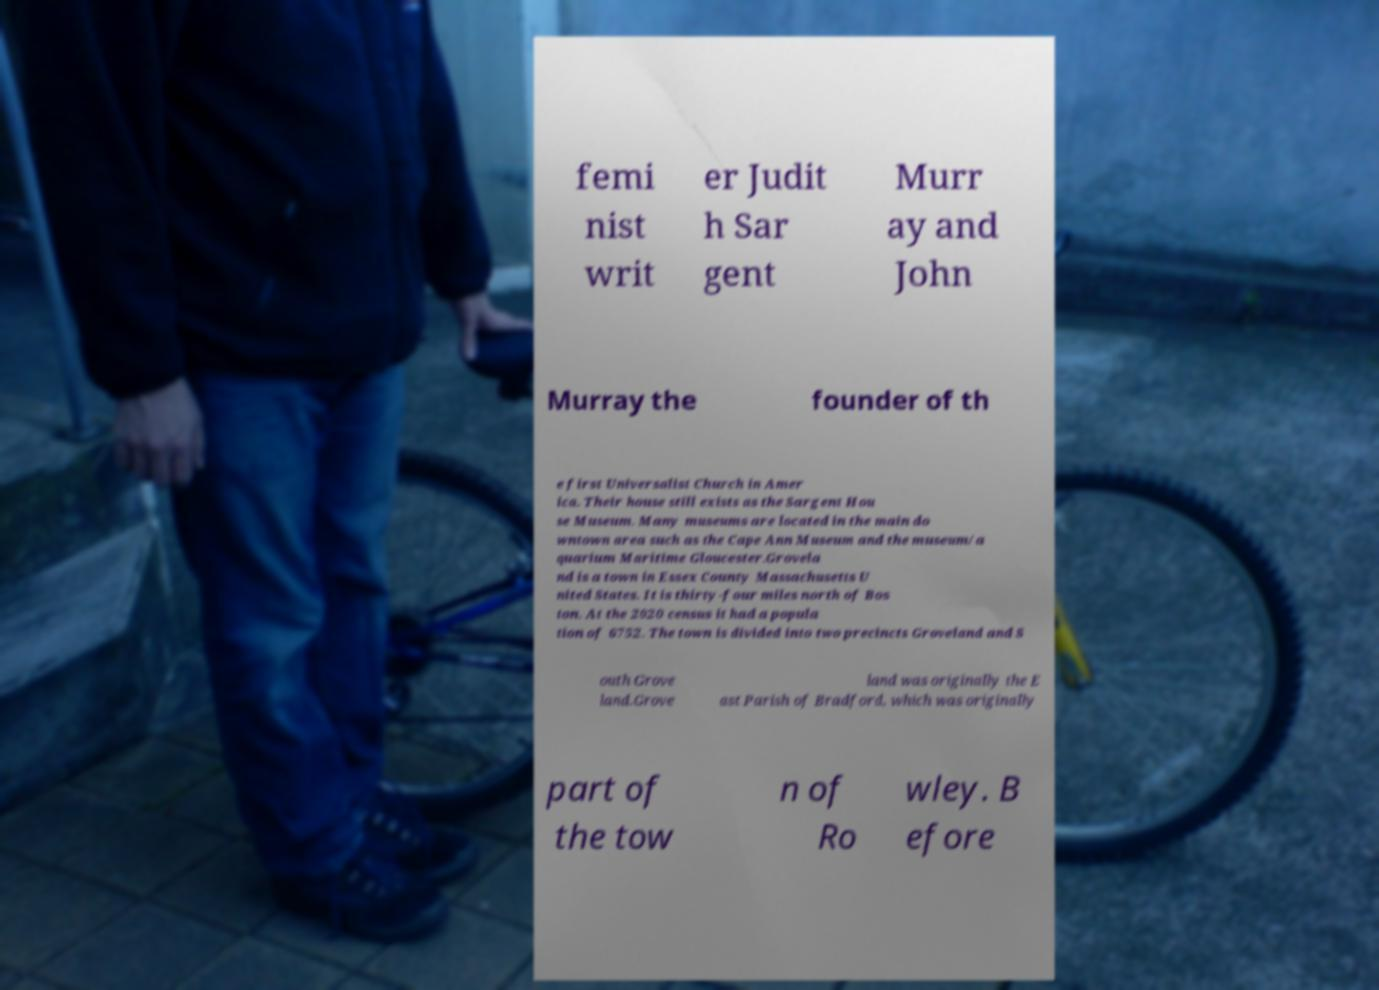What messages or text are displayed in this image? I need them in a readable, typed format. femi nist writ er Judit h Sar gent Murr ay and John Murray the founder of th e first Universalist Church in Amer ica. Their house still exists as the Sargent Hou se Museum. Many museums are located in the main do wntown area such as the Cape Ann Museum and the museum/a quarium Maritime Gloucester.Grovela nd is a town in Essex County Massachusetts U nited States. It is thirty-four miles north of Bos ton. At the 2020 census it had a popula tion of 6752. The town is divided into two precincts Groveland and S outh Grove land.Grove land was originally the E ast Parish of Bradford, which was originally part of the tow n of Ro wley. B efore 